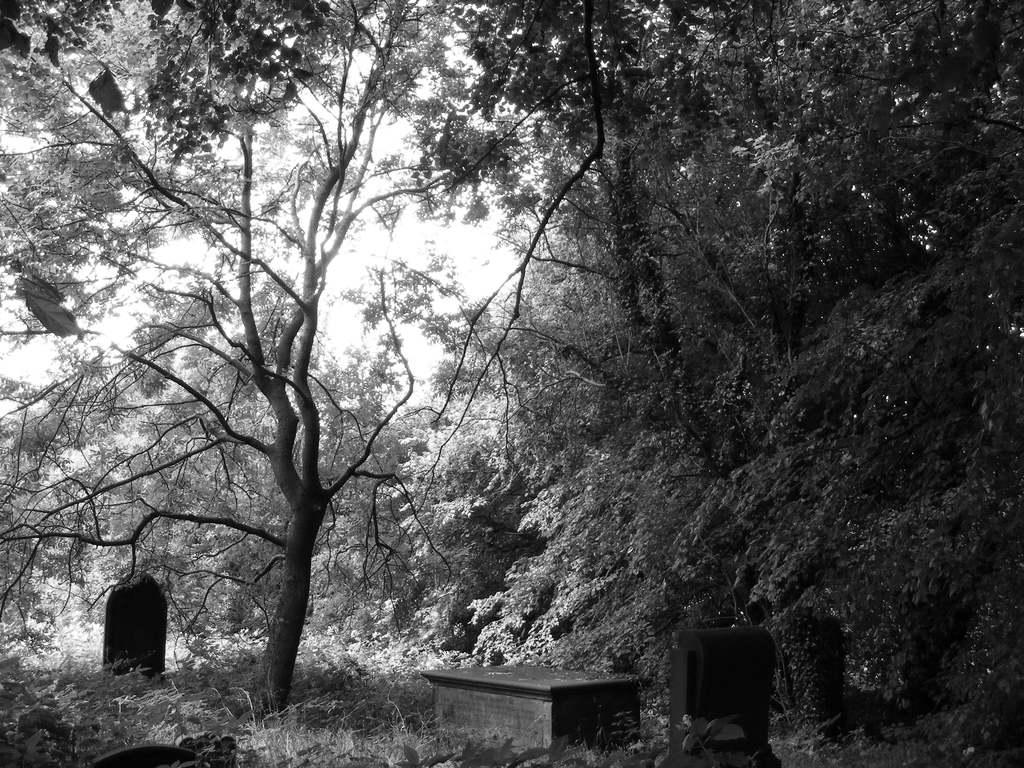What is the color scheme of the image? The image is black and white. What type of object can be seen in the image? There is a bench in the image. What natural elements are present in the image? There is a group of trees in the image. What is visible in the background of the image? The sky is visible in the image. How many times do the people in the image wish for a stitch? There are no people visible in the image, and therefore no one is wishing for a stitch. 